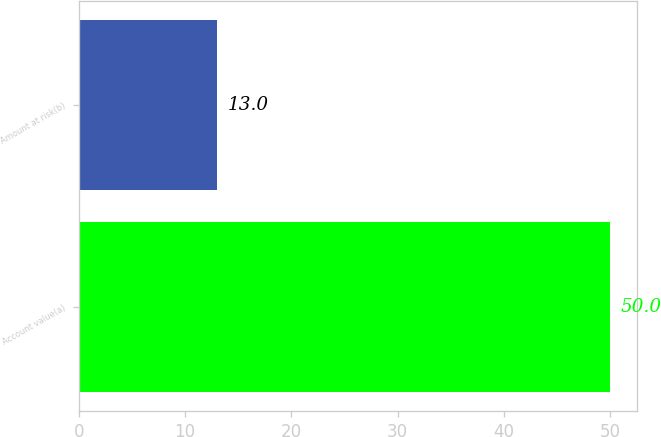Convert chart. <chart><loc_0><loc_0><loc_500><loc_500><bar_chart><fcel>Account value(a)<fcel>Amount at risk(b)<nl><fcel>50<fcel>13<nl></chart> 